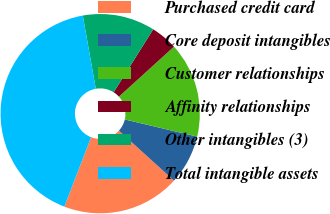Convert chart. <chart><loc_0><loc_0><loc_500><loc_500><pie_chart><fcel>Purchased credit card<fcel>Core deposit intangibles<fcel>Customer relationships<fcel>Affinity relationships<fcel>Other intangibles (3)<fcel>Total intangible assets<nl><fcel>19.13%<fcel>8.03%<fcel>15.43%<fcel>4.33%<fcel>11.73%<fcel>41.34%<nl></chart> 